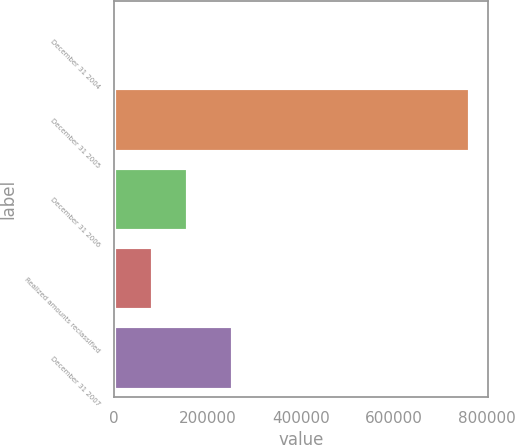Convert chart to OTSL. <chart><loc_0><loc_0><loc_500><loc_500><bar_chart><fcel>December 31 2004<fcel>December 31 2005<fcel>December 31 2006<fcel>Realized amounts reclassified<fcel>December 31 2007<nl><fcel>6939<fcel>763834<fcel>158318<fcel>82628.5<fcel>254798<nl></chart> 